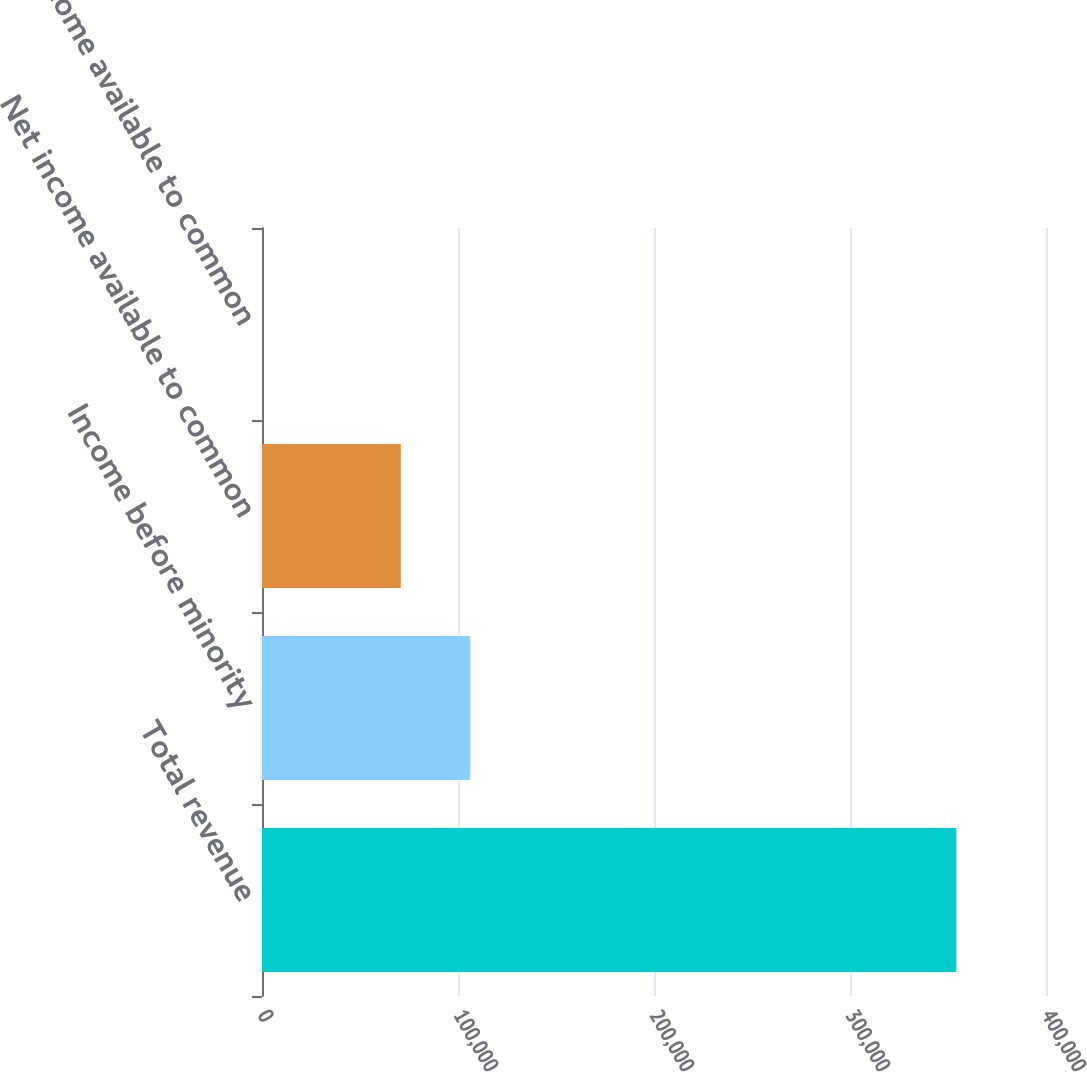Convert chart to OTSL. <chart><loc_0><loc_0><loc_500><loc_500><bar_chart><fcel>Total revenue<fcel>Income before minority<fcel>Net income available to common<fcel>Income available to common<nl><fcel>354273<fcel>106282<fcel>70855.1<fcel>0.55<nl></chart> 